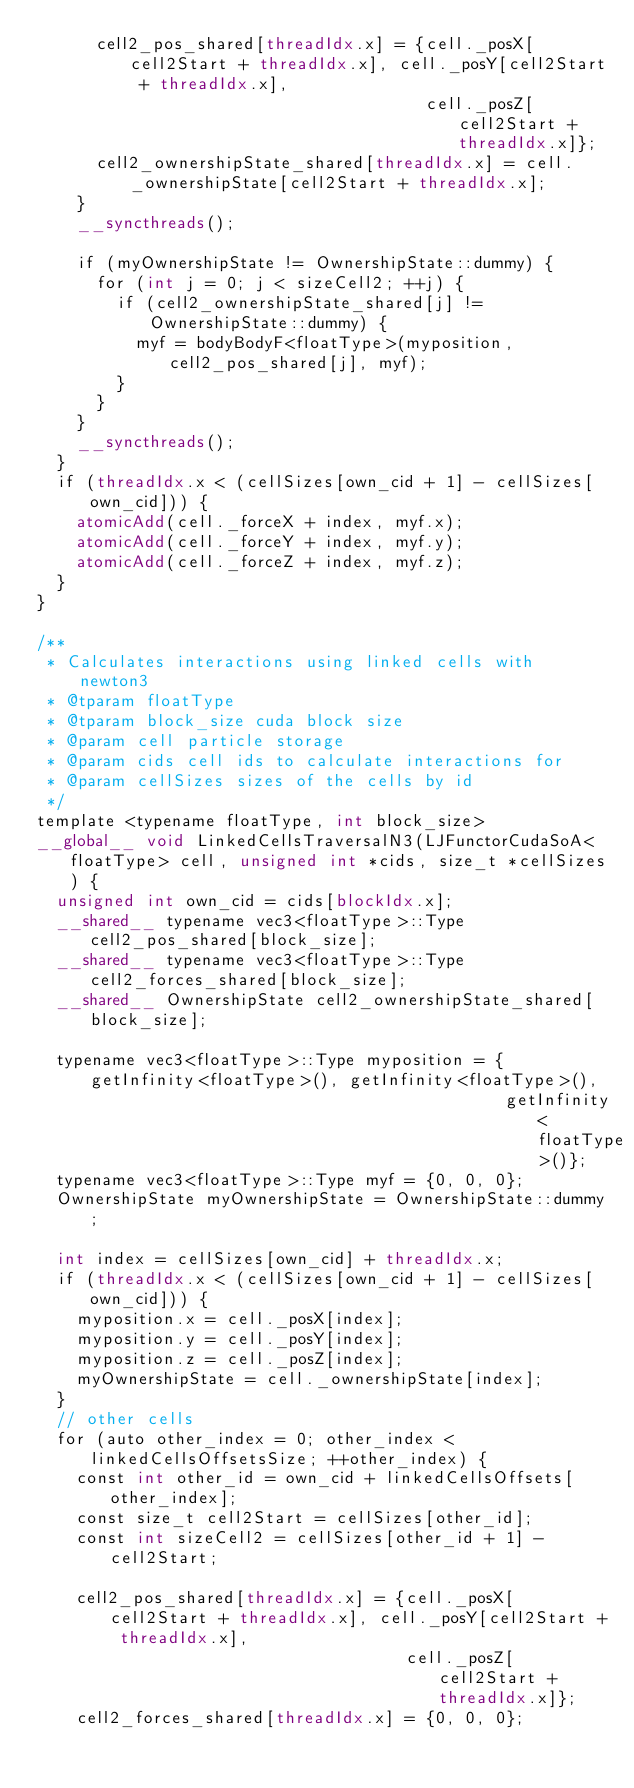Convert code to text. <code><loc_0><loc_0><loc_500><loc_500><_Cuda_>      cell2_pos_shared[threadIdx.x] = {cell._posX[cell2Start + threadIdx.x], cell._posY[cell2Start + threadIdx.x],
                                       cell._posZ[cell2Start + threadIdx.x]};
      cell2_ownershipState_shared[threadIdx.x] = cell._ownershipState[cell2Start + threadIdx.x];
    }
    __syncthreads();

    if (myOwnershipState != OwnershipState::dummy) {
      for (int j = 0; j < sizeCell2; ++j) {
        if (cell2_ownershipState_shared[j] != OwnershipState::dummy) {
          myf = bodyBodyF<floatType>(myposition, cell2_pos_shared[j], myf);
        }
      }
    }
    __syncthreads();
  }
  if (threadIdx.x < (cellSizes[own_cid + 1] - cellSizes[own_cid])) {
    atomicAdd(cell._forceX + index, myf.x);
    atomicAdd(cell._forceY + index, myf.y);
    atomicAdd(cell._forceZ + index, myf.z);
  }
}

/**
 * Calculates interactions using linked cells with newton3
 * @tparam floatType
 * @tparam block_size cuda block size
 * @param cell particle storage
 * @param cids cell ids to calculate interactions for
 * @param cellSizes sizes of the cells by id
 */
template <typename floatType, int block_size>
__global__ void LinkedCellsTraversalN3(LJFunctorCudaSoA<floatType> cell, unsigned int *cids, size_t *cellSizes) {
  unsigned int own_cid = cids[blockIdx.x];
  __shared__ typename vec3<floatType>::Type cell2_pos_shared[block_size];
  __shared__ typename vec3<floatType>::Type cell2_forces_shared[block_size];
  __shared__ OwnershipState cell2_ownershipState_shared[block_size];

  typename vec3<floatType>::Type myposition = {getInfinity<floatType>(), getInfinity<floatType>(),
                                               getInfinity<floatType>()};
  typename vec3<floatType>::Type myf = {0, 0, 0};
  OwnershipState myOwnershipState = OwnershipState::dummy;

  int index = cellSizes[own_cid] + threadIdx.x;
  if (threadIdx.x < (cellSizes[own_cid + 1] - cellSizes[own_cid])) {
    myposition.x = cell._posX[index];
    myposition.y = cell._posY[index];
    myposition.z = cell._posZ[index];
    myOwnershipState = cell._ownershipState[index];
  }
  // other cells
  for (auto other_index = 0; other_index < linkedCellsOffsetsSize; ++other_index) {
    const int other_id = own_cid + linkedCellsOffsets[other_index];
    const size_t cell2Start = cellSizes[other_id];
    const int sizeCell2 = cellSizes[other_id + 1] - cell2Start;

    cell2_pos_shared[threadIdx.x] = {cell._posX[cell2Start + threadIdx.x], cell._posY[cell2Start + threadIdx.x],
                                     cell._posZ[cell2Start + threadIdx.x]};
    cell2_forces_shared[threadIdx.x] = {0, 0, 0};</code> 